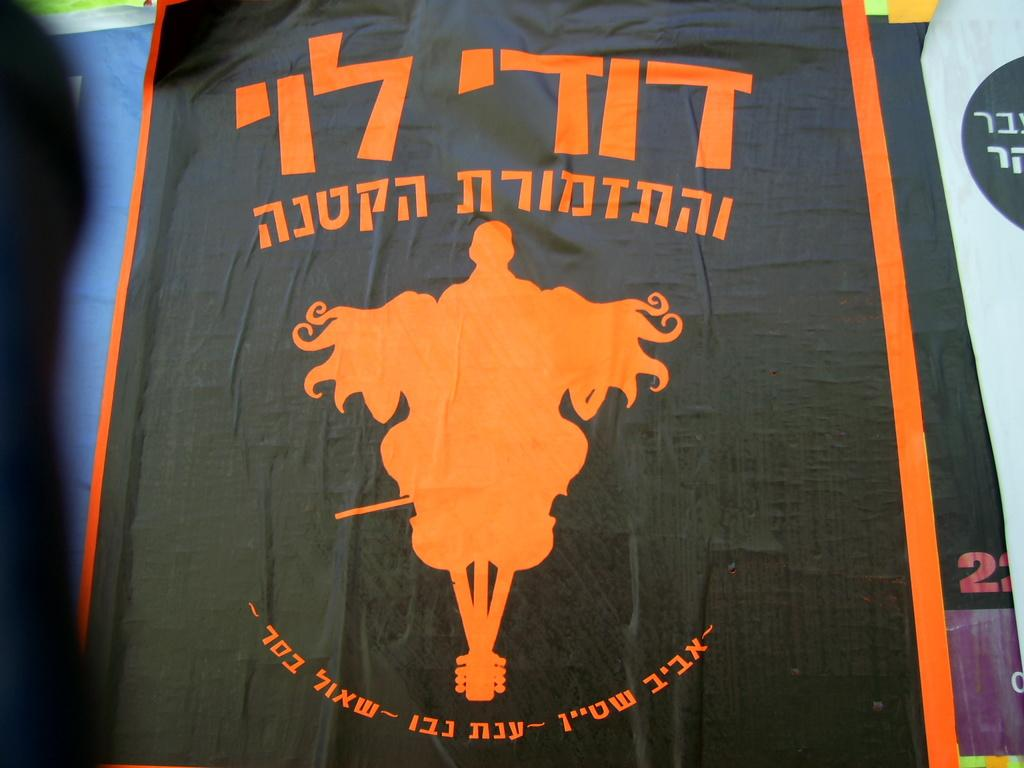What is the main subject in the center of the image? There is a black cloth in the center of the image. What color is the design on the black cloth? The design on the black cloth is orange. What else can be seen on the black cloth? There is text written on the cloth. Can you hear the cloth laughing in the image? The cloth does not make any sound, including laughter, in the image. 